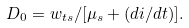<formula> <loc_0><loc_0><loc_500><loc_500>D _ { 0 } = w _ { t s } / [ \mu _ { s } + ( d i / d t ) ] .</formula> 